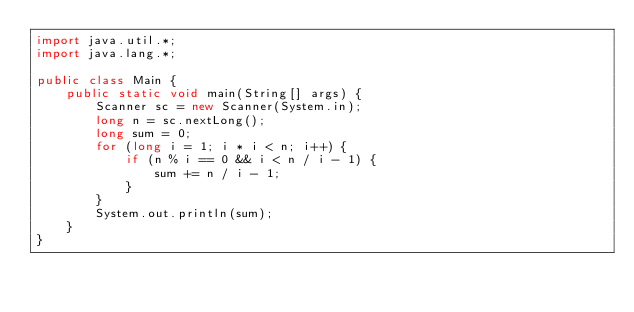Convert code to text. <code><loc_0><loc_0><loc_500><loc_500><_Java_>import java.util.*;
import java.lang.*;

public class Main {
	public static void main(String[] args) {
		Scanner sc = new Scanner(System.in);
		long n = sc.nextLong();
		long sum = 0;
		for (long i = 1; i * i < n; i++) {
			if (n % i == 0 && i < n / i - 1) {
				sum += n / i - 1;
			}
		}
		System.out.println(sum);
	}
}</code> 